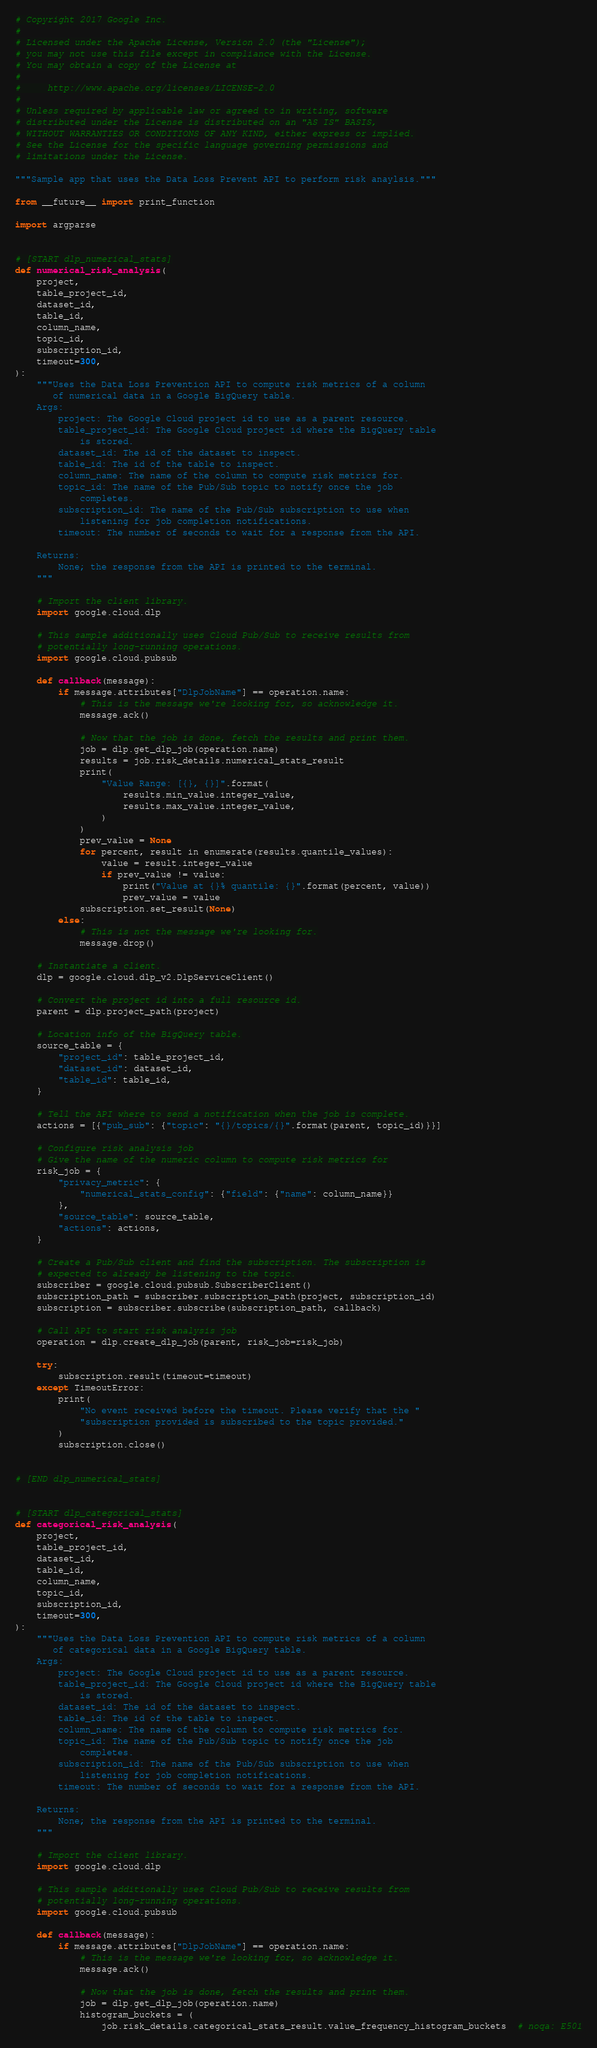Convert code to text. <code><loc_0><loc_0><loc_500><loc_500><_Python_># Copyright 2017 Google Inc.
#
# Licensed under the Apache License, Version 2.0 (the "License");
# you may not use this file except in compliance with the License.
# You may obtain a copy of the License at
#
#     http://www.apache.org/licenses/LICENSE-2.0
#
# Unless required by applicable law or agreed to in writing, software
# distributed under the License is distributed on an "AS IS" BASIS,
# WITHOUT WARRANTIES OR CONDITIONS OF ANY KIND, either express or implied.
# See the License for the specific language governing permissions and
# limitations under the License.

"""Sample app that uses the Data Loss Prevent API to perform risk anaylsis."""

from __future__ import print_function

import argparse


# [START dlp_numerical_stats]
def numerical_risk_analysis(
    project,
    table_project_id,
    dataset_id,
    table_id,
    column_name,
    topic_id,
    subscription_id,
    timeout=300,
):
    """Uses the Data Loss Prevention API to compute risk metrics of a column
       of numerical data in a Google BigQuery table.
    Args:
        project: The Google Cloud project id to use as a parent resource.
        table_project_id: The Google Cloud project id where the BigQuery table
            is stored.
        dataset_id: The id of the dataset to inspect.
        table_id: The id of the table to inspect.
        column_name: The name of the column to compute risk metrics for.
        topic_id: The name of the Pub/Sub topic to notify once the job
            completes.
        subscription_id: The name of the Pub/Sub subscription to use when
            listening for job completion notifications.
        timeout: The number of seconds to wait for a response from the API.

    Returns:
        None; the response from the API is printed to the terminal.
    """

    # Import the client library.
    import google.cloud.dlp

    # This sample additionally uses Cloud Pub/Sub to receive results from
    # potentially long-running operations.
    import google.cloud.pubsub

    def callback(message):
        if message.attributes["DlpJobName"] == operation.name:
            # This is the message we're looking for, so acknowledge it.
            message.ack()

            # Now that the job is done, fetch the results and print them.
            job = dlp.get_dlp_job(operation.name)
            results = job.risk_details.numerical_stats_result
            print(
                "Value Range: [{}, {}]".format(
                    results.min_value.integer_value,
                    results.max_value.integer_value,
                )
            )
            prev_value = None
            for percent, result in enumerate(results.quantile_values):
                value = result.integer_value
                if prev_value != value:
                    print("Value at {}% quantile: {}".format(percent, value))
                    prev_value = value
            subscription.set_result(None)
        else:
            # This is not the message we're looking for.
            message.drop()

    # Instantiate a client.
    dlp = google.cloud.dlp_v2.DlpServiceClient()

    # Convert the project id into a full resource id.
    parent = dlp.project_path(project)

    # Location info of the BigQuery table.
    source_table = {
        "project_id": table_project_id,
        "dataset_id": dataset_id,
        "table_id": table_id,
    }

    # Tell the API where to send a notification when the job is complete.
    actions = [{"pub_sub": {"topic": "{}/topics/{}".format(parent, topic_id)}}]

    # Configure risk analysis job
    # Give the name of the numeric column to compute risk metrics for
    risk_job = {
        "privacy_metric": {
            "numerical_stats_config": {"field": {"name": column_name}}
        },
        "source_table": source_table,
        "actions": actions,
    }

    # Create a Pub/Sub client and find the subscription. The subscription is
    # expected to already be listening to the topic.
    subscriber = google.cloud.pubsub.SubscriberClient()
    subscription_path = subscriber.subscription_path(project, subscription_id)
    subscription = subscriber.subscribe(subscription_path, callback)

    # Call API to start risk analysis job
    operation = dlp.create_dlp_job(parent, risk_job=risk_job)

    try:
        subscription.result(timeout=timeout)
    except TimeoutError:
        print(
            "No event received before the timeout. Please verify that the "
            "subscription provided is subscribed to the topic provided."
        )
        subscription.close()


# [END dlp_numerical_stats]


# [START dlp_categorical_stats]
def categorical_risk_analysis(
    project,
    table_project_id,
    dataset_id,
    table_id,
    column_name,
    topic_id,
    subscription_id,
    timeout=300,
):
    """Uses the Data Loss Prevention API to compute risk metrics of a column
       of categorical data in a Google BigQuery table.
    Args:
        project: The Google Cloud project id to use as a parent resource.
        table_project_id: The Google Cloud project id where the BigQuery table
            is stored.
        dataset_id: The id of the dataset to inspect.
        table_id: The id of the table to inspect.
        column_name: The name of the column to compute risk metrics for.
        topic_id: The name of the Pub/Sub topic to notify once the job
            completes.
        subscription_id: The name of the Pub/Sub subscription to use when
            listening for job completion notifications.
        timeout: The number of seconds to wait for a response from the API.

    Returns:
        None; the response from the API is printed to the terminal.
    """

    # Import the client library.
    import google.cloud.dlp

    # This sample additionally uses Cloud Pub/Sub to receive results from
    # potentially long-running operations.
    import google.cloud.pubsub

    def callback(message):
        if message.attributes["DlpJobName"] == operation.name:
            # This is the message we're looking for, so acknowledge it.
            message.ack()

            # Now that the job is done, fetch the results and print them.
            job = dlp.get_dlp_job(operation.name)
            histogram_buckets = (
                job.risk_details.categorical_stats_result.value_frequency_histogram_buckets  # noqa: E501</code> 